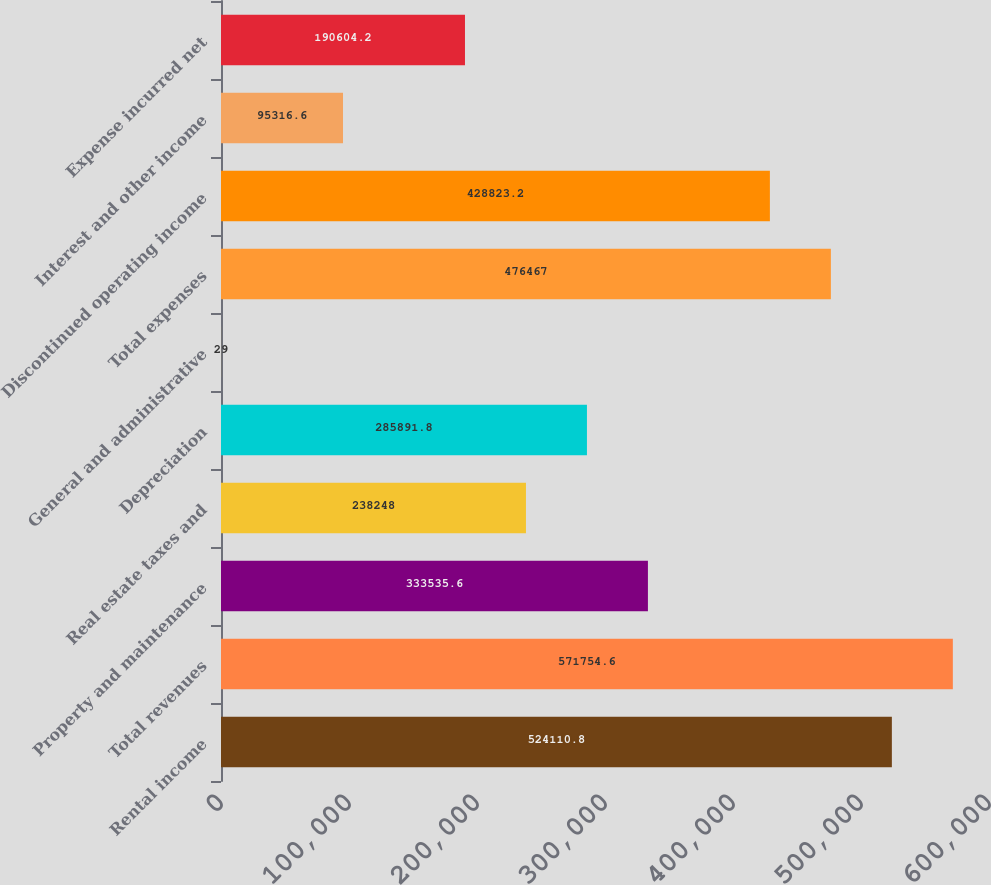<chart> <loc_0><loc_0><loc_500><loc_500><bar_chart><fcel>Rental income<fcel>Total revenues<fcel>Property and maintenance<fcel>Real estate taxes and<fcel>Depreciation<fcel>General and administrative<fcel>Total expenses<fcel>Discontinued operating income<fcel>Interest and other income<fcel>Expense incurred net<nl><fcel>524111<fcel>571755<fcel>333536<fcel>238248<fcel>285892<fcel>29<fcel>476467<fcel>428823<fcel>95316.6<fcel>190604<nl></chart> 